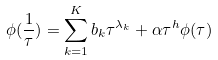<formula> <loc_0><loc_0><loc_500><loc_500>\phi ( \frac { 1 } { \tau } ) = \sum _ { k = 1 } ^ { K } b _ { k } \tau ^ { \lambda _ { k } } + \alpha \tau ^ { h } \phi ( \tau )</formula> 